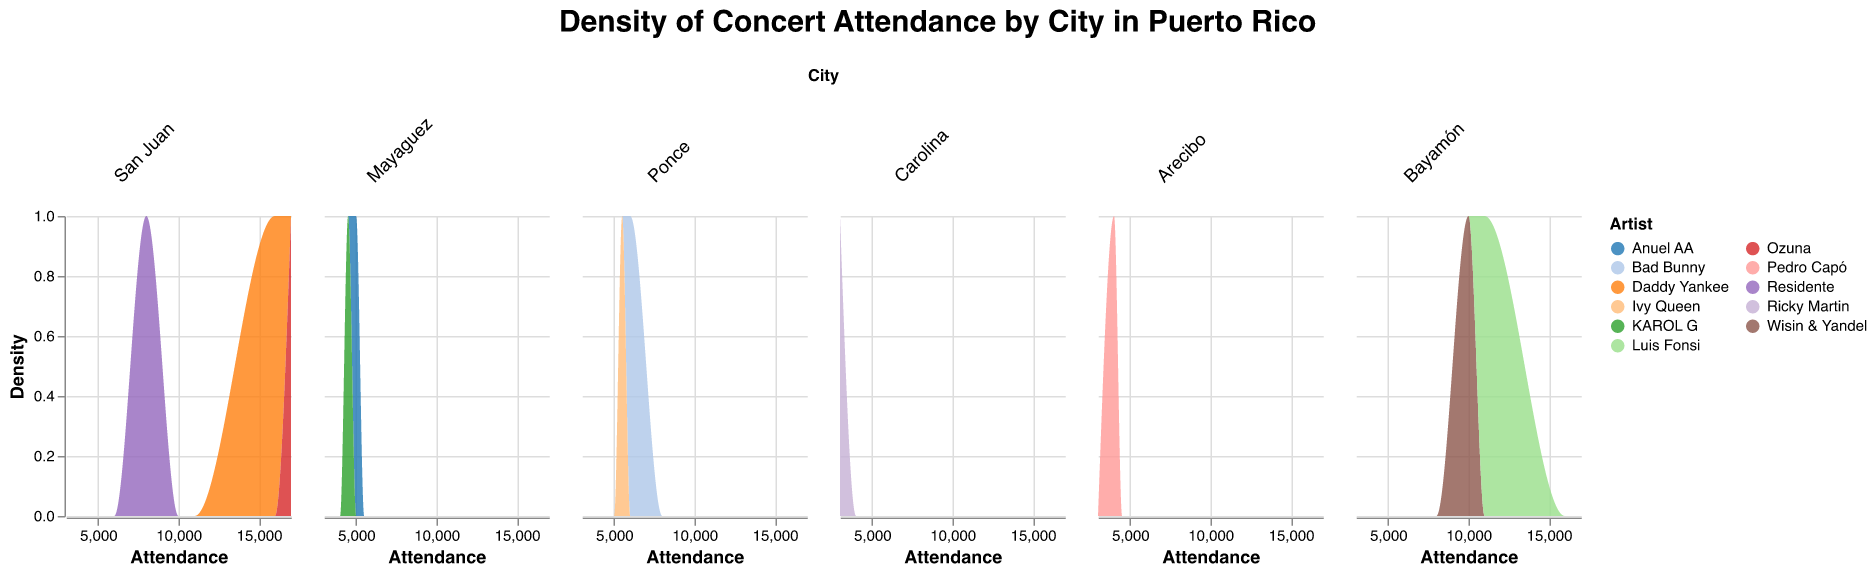What's the highest attendance observed in any of the cities? By observing the density plots, the highest attendance is for an artist performing at San Juan's Coliseo de Puerto Rico. The attendance is near the venue capacity of 18,000.
Answer: 17,000 Which city shows the widest range of attendance values? The density plot for San Juan shows a very wide range of attendance values, from around 8,000 to 17,000. This indicates a large variation.
Answer: San Juan In which city does an artist almost fill the venue to its full capacity? Looking at the density plot for Mayaguez, there are artists that have attendance numbers very close to the venue size of 5,000. Both Anuel AA and KAROL G have attendance close to the capacity.
Answer: Mayaguez For Bayamón, which artist has the higher attendance, Wisin & Yandel or Luis Fonsi? By comparing the peaks in the density plot for Bayamón, Luis Fonsi has an attendance of around 11,000, which is higher than Wisin & Yandel at around 10,000.
Answer: Luis Fonsi What is the average attendance for concerts held in San Juan? In San Juan, there are three concerts with attendance 8,000, 16,000, and 17,000. The average attendance can be calculated by summing them up (8,000 + 16,000 + 17,000) = 41,000 and then dividing by 3 (41,000 / 3).
Answer: 13,666.67 Is there any city where the attendance is uniform across all concerts? In the density plot, Ponce shows a relatively uniform distribution with Bad Bunny at 6,000 and Ivy Queen at 5,500, indicating more uniform attendance.
Answer: Ponce Which city has the lowest maximum attendance for any concert? The density plot for Carolina shows the lowest maximum attendance, with Ricky Martin having about 3,000 attendees.
Answer: Carolina How do the attendance ranges in Mayaguez compare between the two artists? In Mayaguez, Anuel AA has an attendance of 5,000 and KAROL G has an attendance of 4,500. The difference is 500 attendees, which shows relatively close attendance values.
Answer: 500 